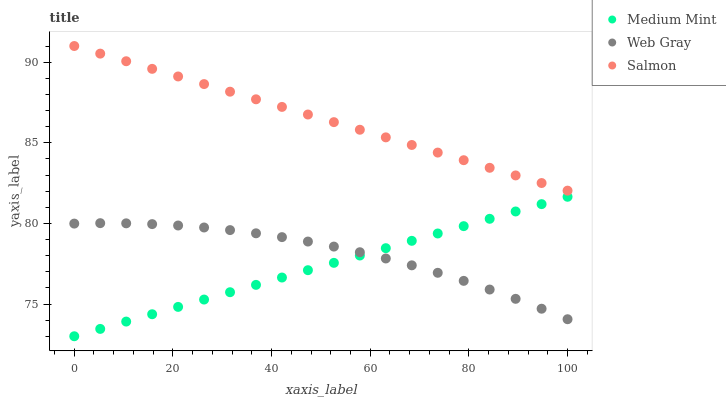Does Medium Mint have the minimum area under the curve?
Answer yes or no. Yes. Does Salmon have the maximum area under the curve?
Answer yes or no. Yes. Does Web Gray have the minimum area under the curve?
Answer yes or no. No. Does Web Gray have the maximum area under the curve?
Answer yes or no. No. Is Salmon the smoothest?
Answer yes or no. Yes. Is Web Gray the roughest?
Answer yes or no. Yes. Is Web Gray the smoothest?
Answer yes or no. No. Is Salmon the roughest?
Answer yes or no. No. Does Medium Mint have the lowest value?
Answer yes or no. Yes. Does Web Gray have the lowest value?
Answer yes or no. No. Does Salmon have the highest value?
Answer yes or no. Yes. Does Web Gray have the highest value?
Answer yes or no. No. Is Medium Mint less than Salmon?
Answer yes or no. Yes. Is Salmon greater than Web Gray?
Answer yes or no. Yes. Does Medium Mint intersect Web Gray?
Answer yes or no. Yes. Is Medium Mint less than Web Gray?
Answer yes or no. No. Is Medium Mint greater than Web Gray?
Answer yes or no. No. Does Medium Mint intersect Salmon?
Answer yes or no. No. 